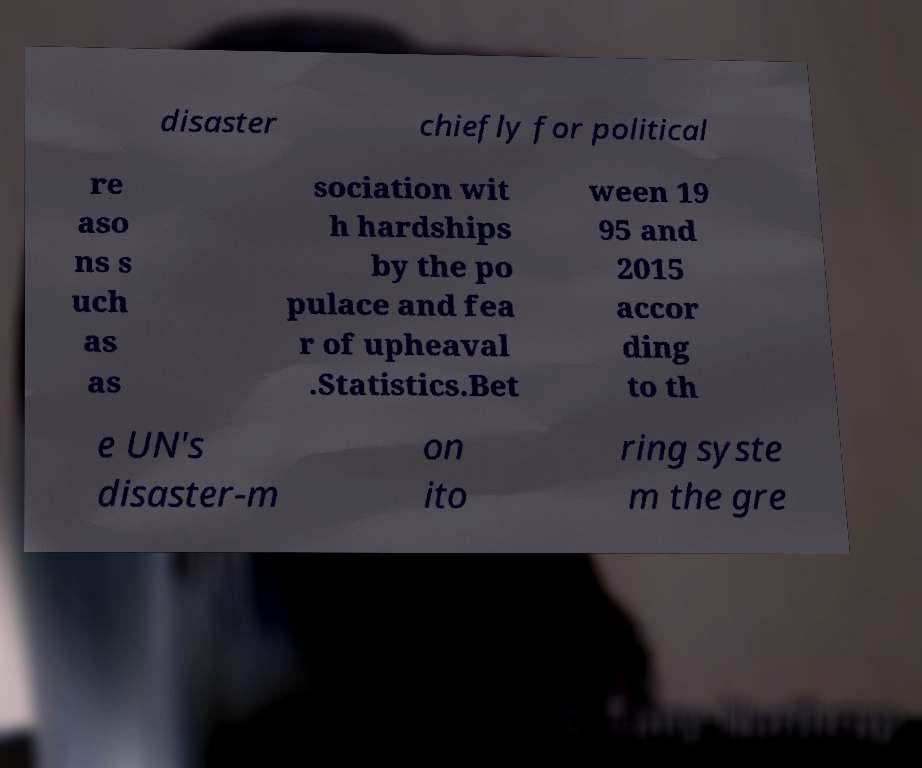Please read and relay the text visible in this image. What does it say? disaster chiefly for political re aso ns s uch as as sociation wit h hardships by the po pulace and fea r of upheaval .Statistics.Bet ween 19 95 and 2015 accor ding to th e UN's disaster-m on ito ring syste m the gre 